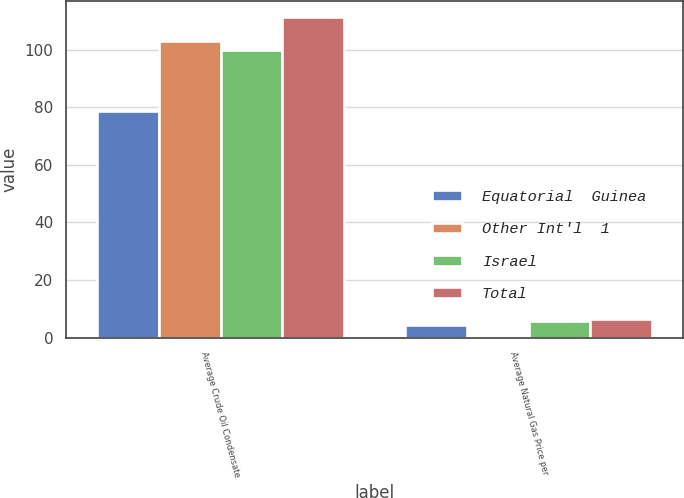Convert chart to OTSL. <chart><loc_0><loc_0><loc_500><loc_500><stacked_bar_chart><ecel><fcel>Average Crude Oil Condensate<fcel>Average Natural Gas Price per<nl><fcel>Equatorial  Guinea<fcel>78.9<fcel>4.24<nl><fcel>Other Int'l  1<fcel>103.01<fcel>0.25<nl><fcel>Israel<fcel>99.92<fcel>5.85<nl><fcel>Total<fcel>111.5<fcel>6.55<nl></chart> 